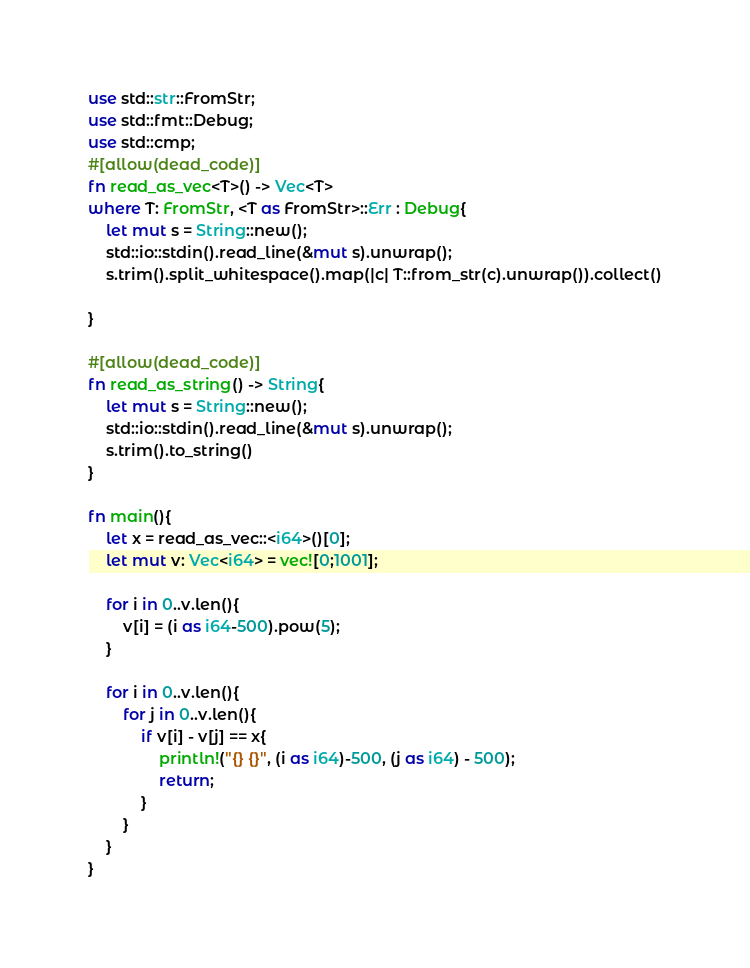Convert code to text. <code><loc_0><loc_0><loc_500><loc_500><_Rust_>use std::str::FromStr;
use std::fmt::Debug;
use std::cmp;
#[allow(dead_code)]
fn read_as_vec<T>() -> Vec<T>
where T: FromStr, <T as FromStr>::Err : Debug{
    let mut s = String::new();
    std::io::stdin().read_line(&mut s).unwrap();
    s.trim().split_whitespace().map(|c| T::from_str(c).unwrap()).collect()

}

#[allow(dead_code)]
fn read_as_string() -> String{
    let mut s = String::new();
    std::io::stdin().read_line(&mut s).unwrap();
    s.trim().to_string()
}

fn main(){
    let x = read_as_vec::<i64>()[0];
    let mut v: Vec<i64> = vec![0;1001];

    for i in 0..v.len(){
        v[i] = (i as i64-500).pow(5);
    }

    for i in 0..v.len(){
        for j in 0..v.len(){
            if v[i] - v[j] == x{
                println!("{} {}", (i as i64)-500, (j as i64) - 500);
                return;
            }
        }
    }
}
</code> 